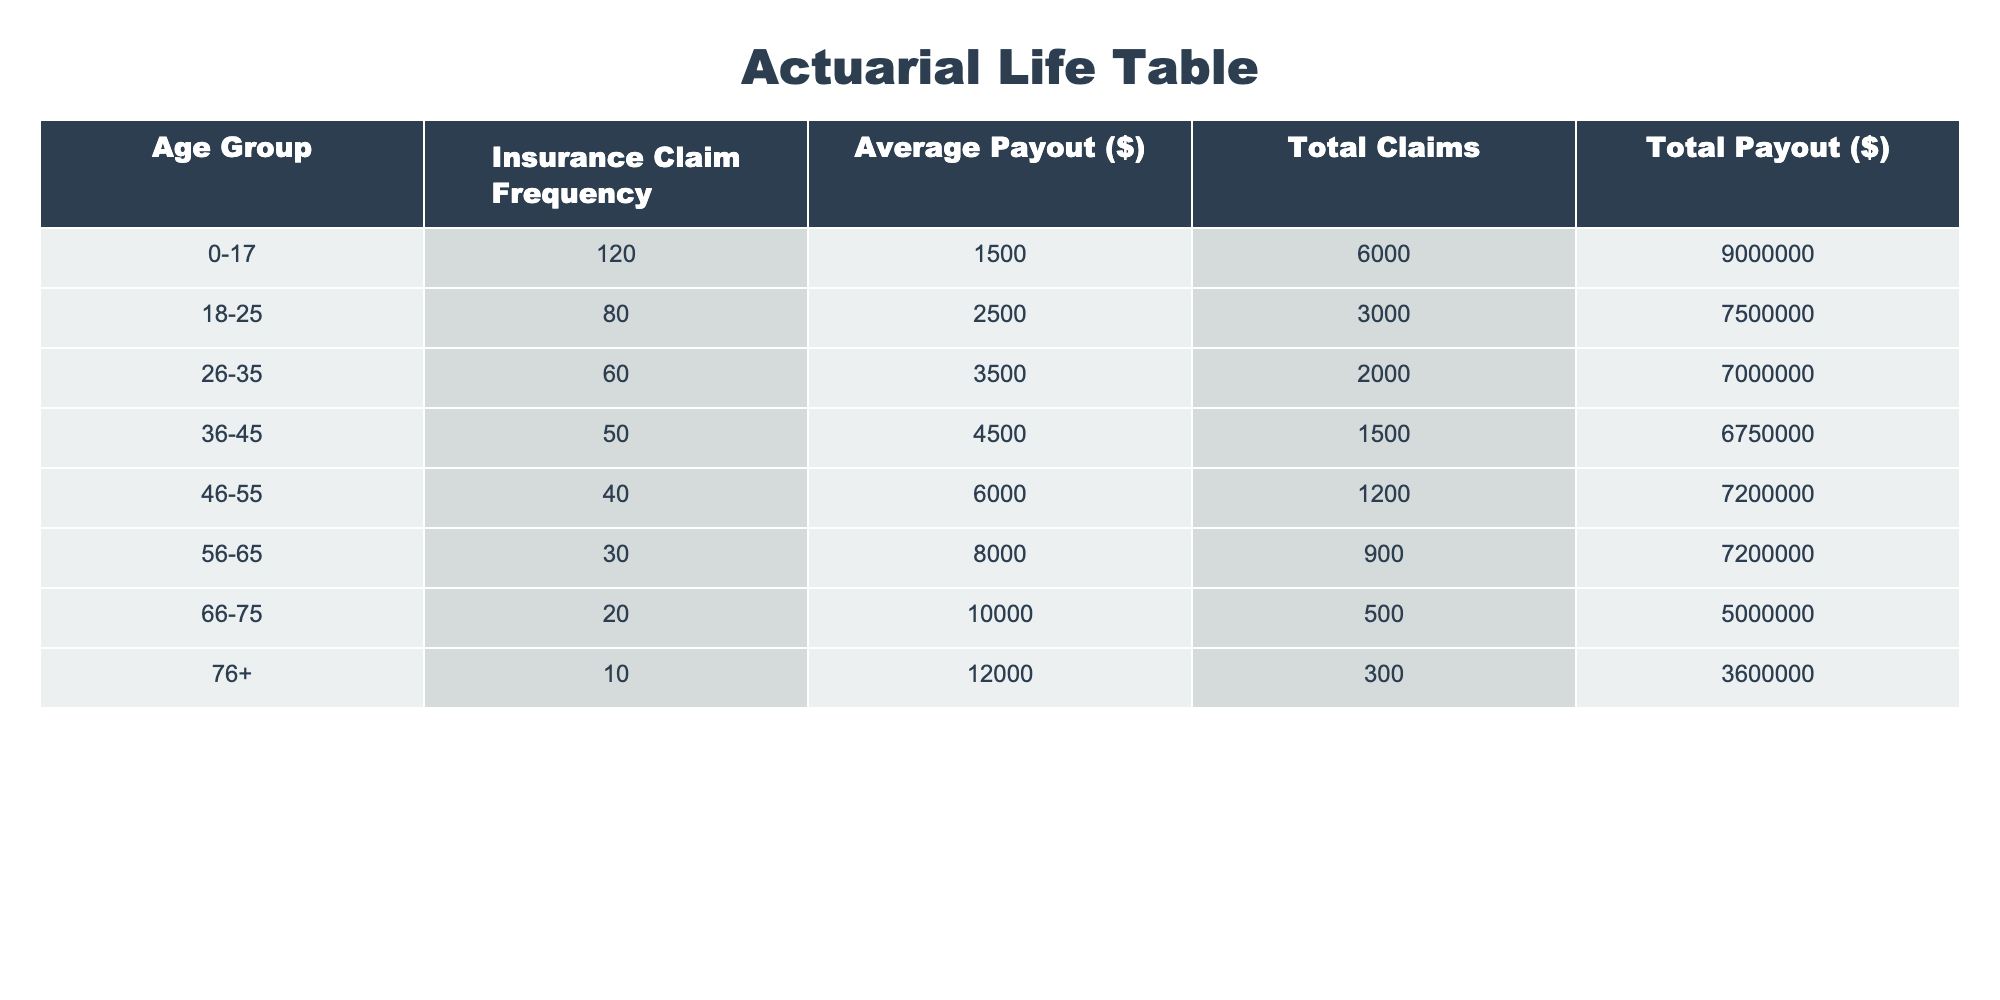What is the average payout for the age group 46-55? The average payout for the age group 46-55 is found directly in the table under the "Average Payout ($)" column for that age group. It shows 6000.
Answer: 6000 How many total claims were made by the age group 36-45? The total claims for the age group 36-45 can be found in the "Total Claims" column. It states that there were 1500 claims made.
Answer: 1500 Is the insurance claim frequency for the age group 56-65 greater than that for the age group 66-75? By comparing the "Insurance Claim Frequency" for both groups in the table, 30 for 56-65 is greater than 20 for 66-75. Hence, the statement is true.
Answer: Yes What is the total payout for the age group 0-17 and 18-25 combined? To find the total payout for both age groups, add the total payouts: 9000000 (0-17) + 7500000 (18-25) = 16500000.
Answer: 16500000 What is the average insurance claim frequency for all age groups combined? First, sum all the insurance claim frequencies: 120 + 80 + 60 + 50 + 40 + 30 + 20 + 10 = 410. Next, divide by the number of age groups, which is 8. Therefore, 410 / 8 = 51.25.
Answer: 51.25 Is it true that the total payout for the age group 76+ is less than that for the age group 66-75? By checking the "Total Payout ($)" values, the total payout for age group 76+ is 3600000 and for 66-75 it is 5000000. Since 3600000 is indeed less than 5000000, the statement is true.
Answer: Yes What is the difference in average payout between age groups 26-35 and 36-45? The average payout for 26-35 is 3500 and for 36-45 is 4500. Their difference is 4500 - 3500 = 1000.
Answer: 1000 Which age group has the lowest claim frequency? In reviewing the "Insurance Claim Frequency" column, the lowest frequency is 10 for the age group 76+.
Answer: 76+ 